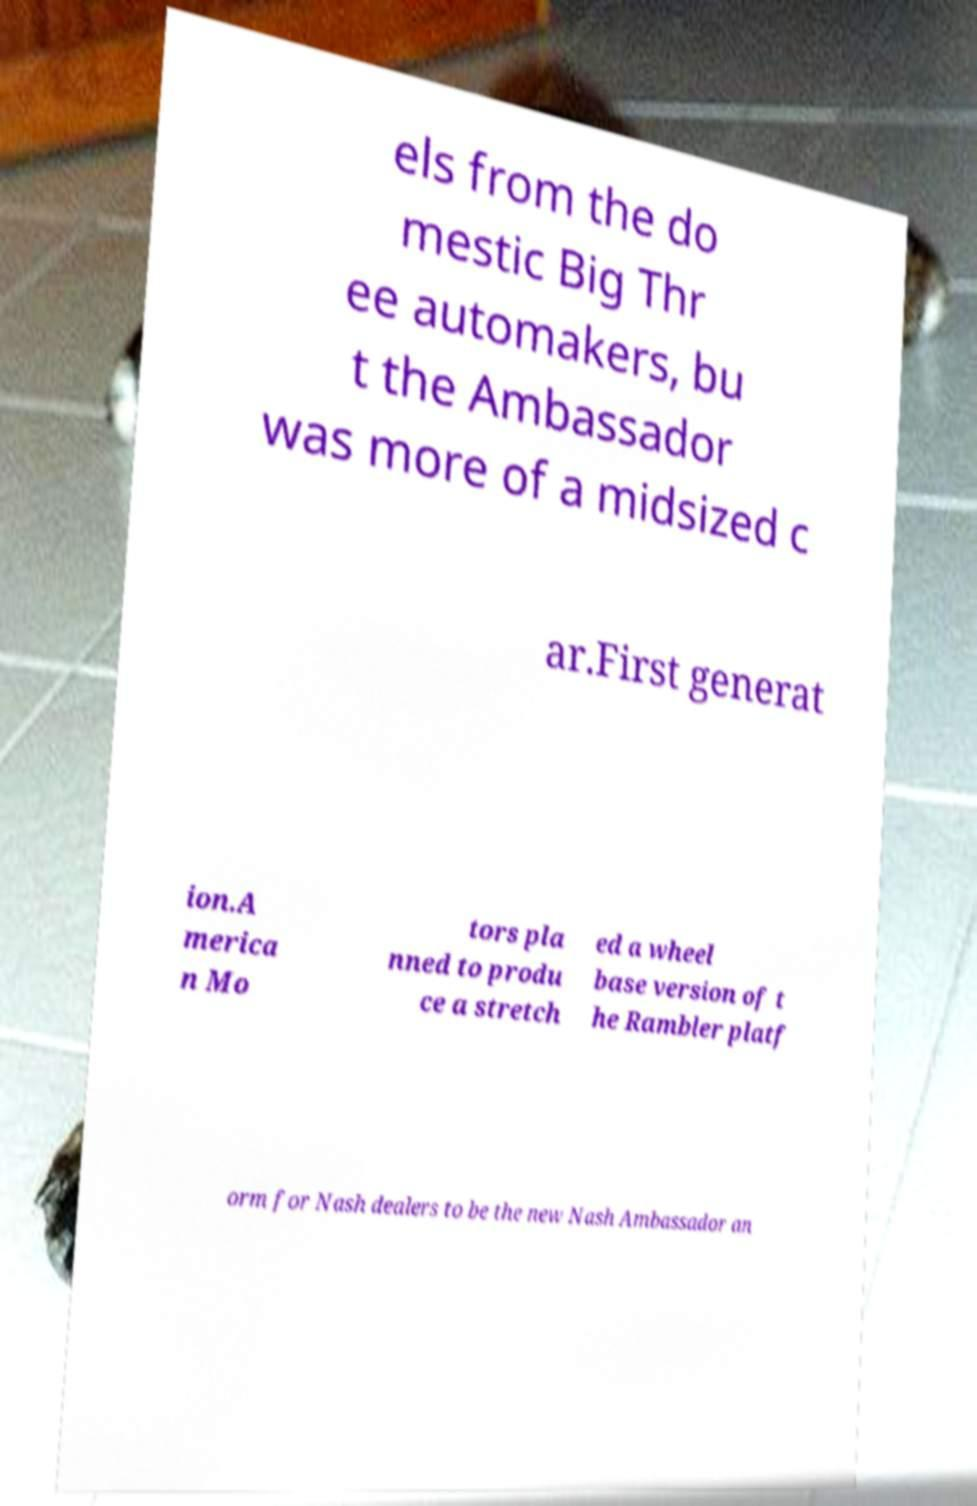Could you extract and type out the text from this image? els from the do mestic Big Thr ee automakers, bu t the Ambassador was more of a midsized c ar.First generat ion.A merica n Mo tors pla nned to produ ce a stretch ed a wheel base version of t he Rambler platf orm for Nash dealers to be the new Nash Ambassador an 